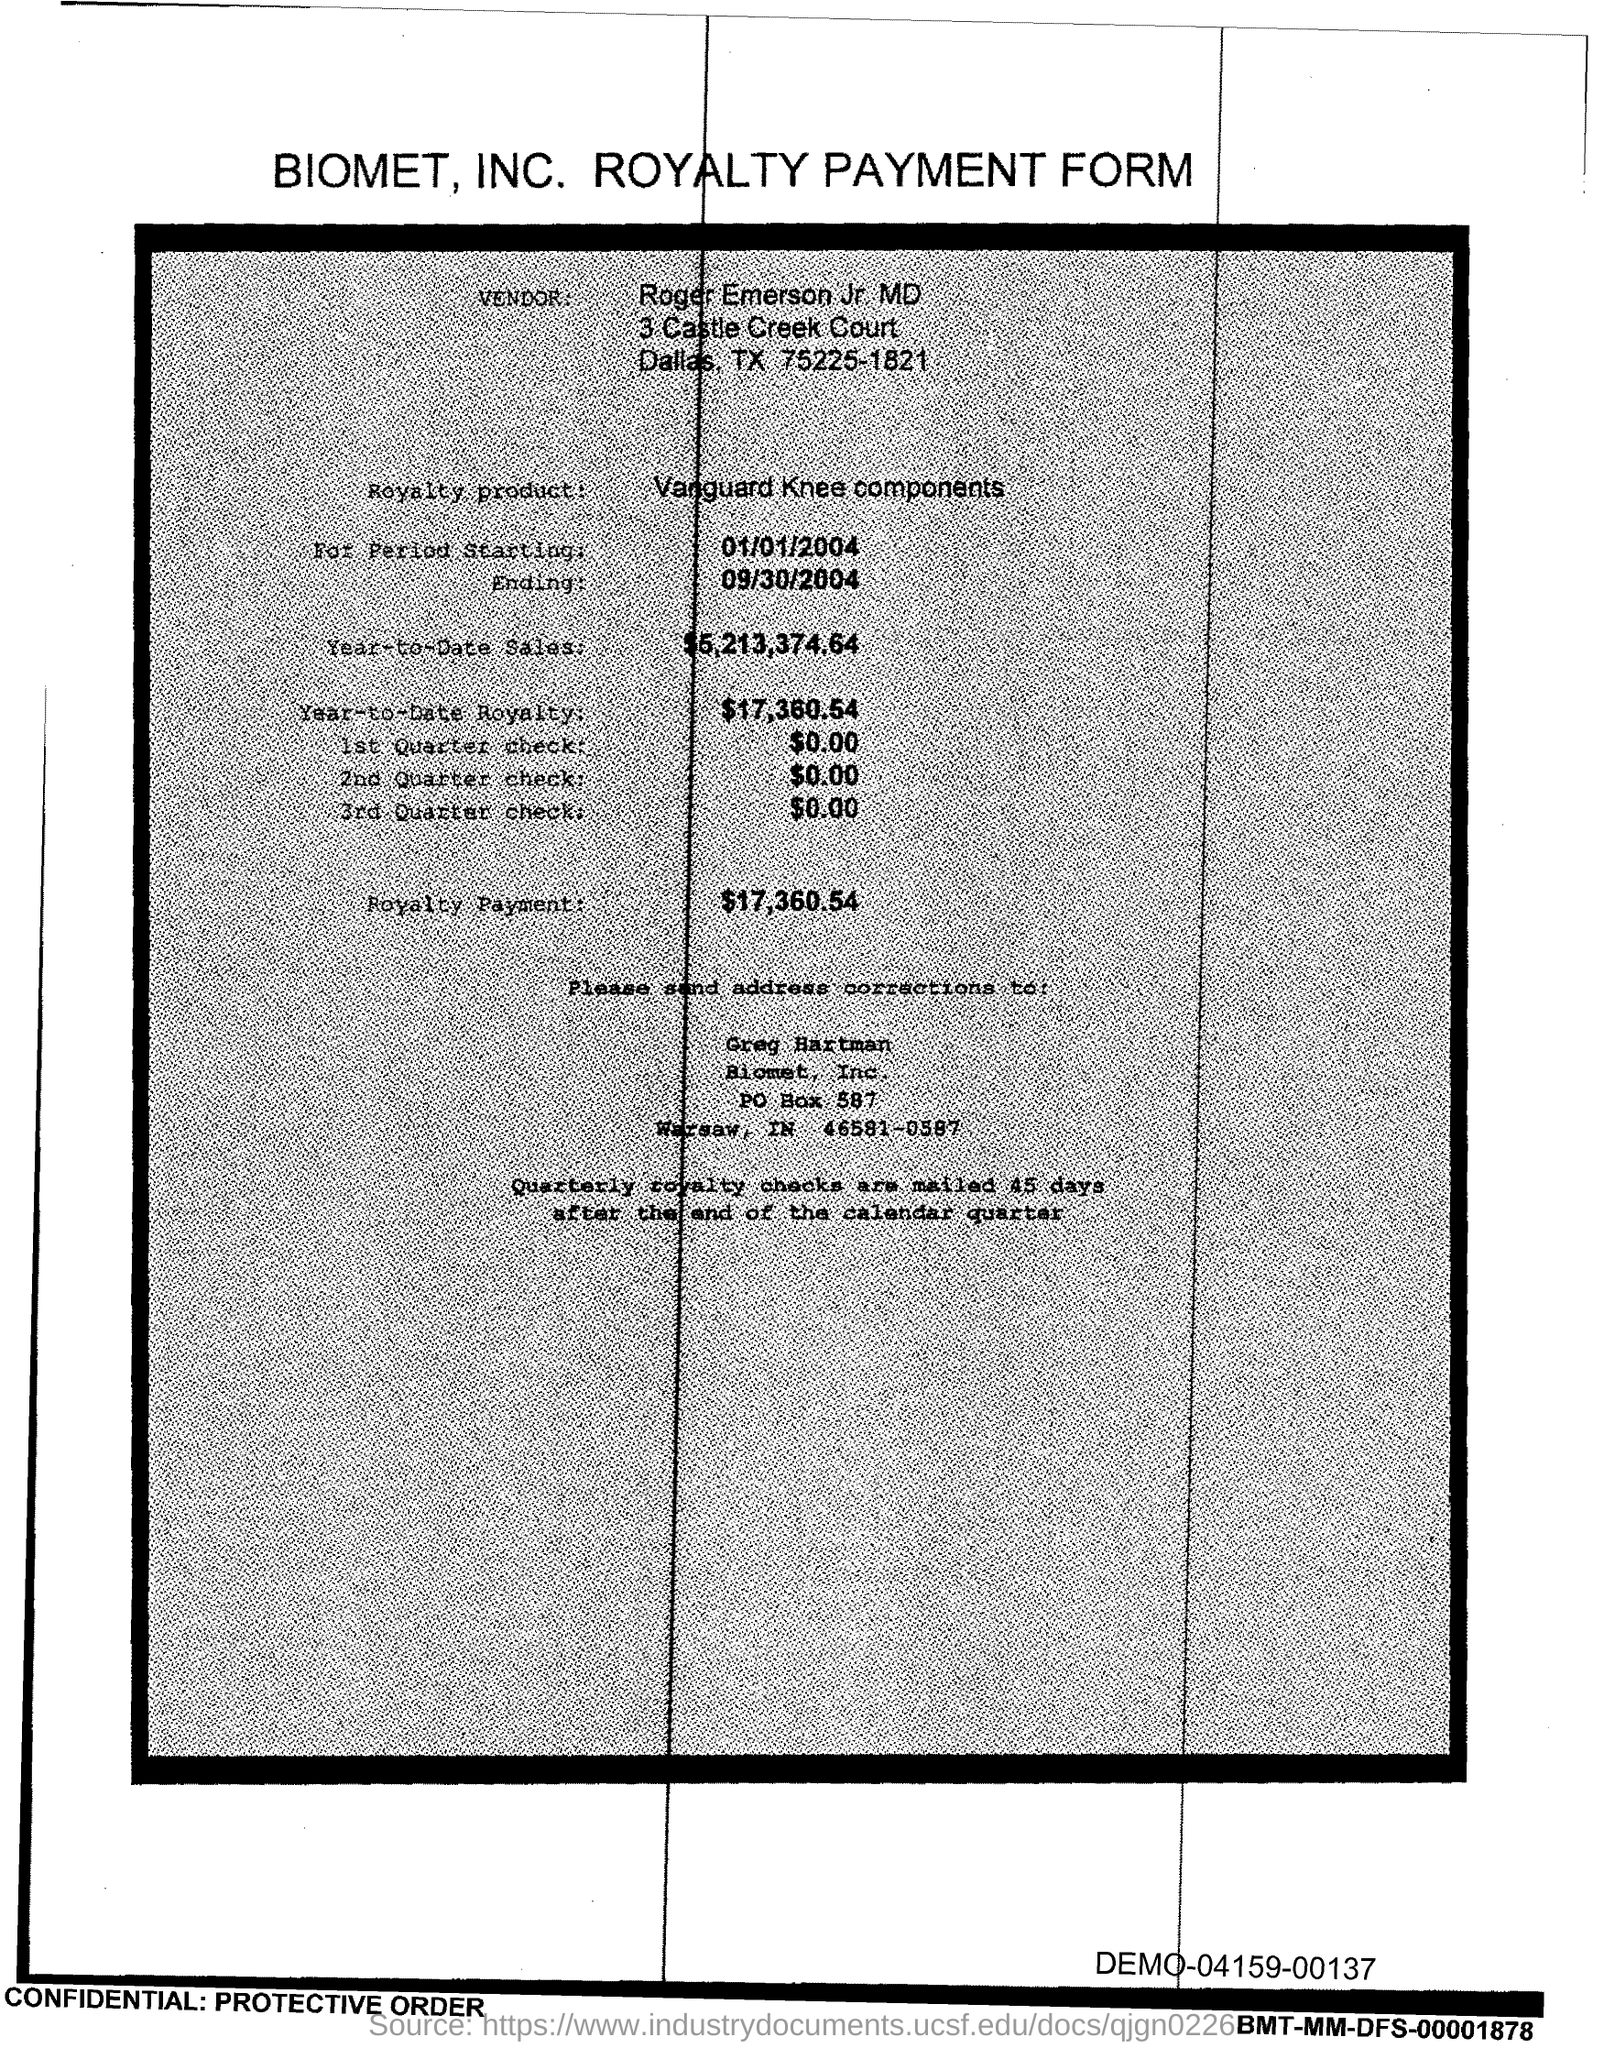Outline some significant characteristics in this image. The royalty payment is $17,360.54. The second quarter check is $0.00. The event is scheduled to end on September 30, 2004. As of the current date, the year-to-date royalty amount is $17,360.54. The year-to-date sales as of now are $5,213,374.64. 